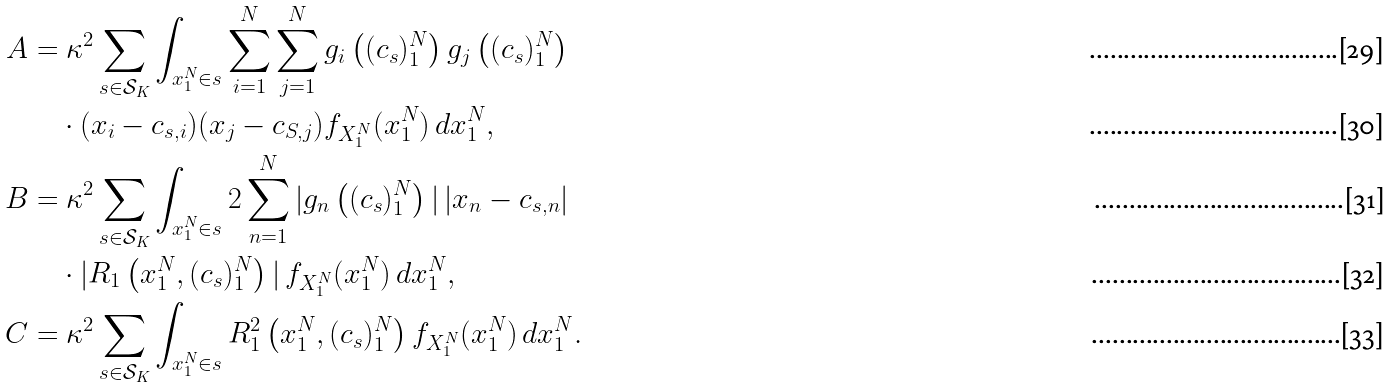<formula> <loc_0><loc_0><loc_500><loc_500>A & = \kappa ^ { 2 } \sum _ { s \in \mathcal { S } _ { K } } \int _ { x _ { 1 } ^ { N } \in s } \sum _ { i = 1 } ^ { N } \sum _ { j = 1 } ^ { N } g _ { i } \left ( ( c _ { s } ) _ { 1 } ^ { N } \right ) g _ { j } \left ( ( c _ { s } ) _ { 1 } ^ { N } \right ) \\ & \quad \cdot ( x _ { i } - c _ { s , i } ) ( x _ { j } - c _ { S , j } ) f _ { X _ { 1 } ^ { N } } ( x _ { 1 } ^ { N } ) \, d x _ { 1 } ^ { N } , \\ B & = \kappa ^ { 2 } \sum _ { s \in \mathcal { S } _ { K } } \int _ { x _ { 1 } ^ { N } \in s } 2 \sum _ { n = 1 } ^ { N } | g _ { n } \left ( ( c _ { s } ) _ { 1 } ^ { N } \right ) | \, | x _ { n } - c _ { s , n } | \\ & \quad \cdot | R _ { 1 } \left ( x _ { 1 } ^ { N } , ( c _ { s } ) _ { 1 } ^ { N } \right ) | \, f _ { X _ { 1 } ^ { N } } ( x _ { 1 } ^ { N } ) \, d x _ { 1 } ^ { N } , \\ C & = \kappa ^ { 2 } \sum _ { s \in \mathcal { S } _ { K } } \int _ { x _ { 1 } ^ { N } \in s } R _ { 1 } ^ { 2 } \left ( x _ { 1 } ^ { N } , ( c _ { s } ) _ { 1 } ^ { N } \right ) f _ { X _ { 1 } ^ { N } } ( x _ { 1 } ^ { N } ) \, d x _ { 1 } ^ { N } .</formula> 